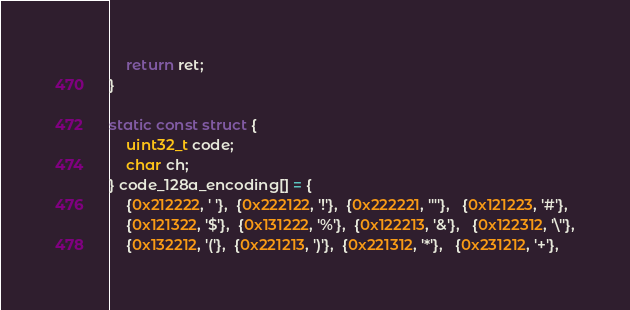Convert code to text. <code><loc_0><loc_0><loc_500><loc_500><_C_>
    return ret;
}

static const struct {
    uint32_t code;
    char ch;
} code_128a_encoding[] = {
    {0x212222, ' '},  {0x222122, '!'},  {0x222221, '"'},   {0x121223, '#'},
    {0x121322, '$'},  {0x131222, '%'},  {0x122213, '&'},   {0x122312, '\''},
    {0x132212, '('},  {0x221213, ')'},  {0x221312, '*'},   {0x231212, '+'},</code> 